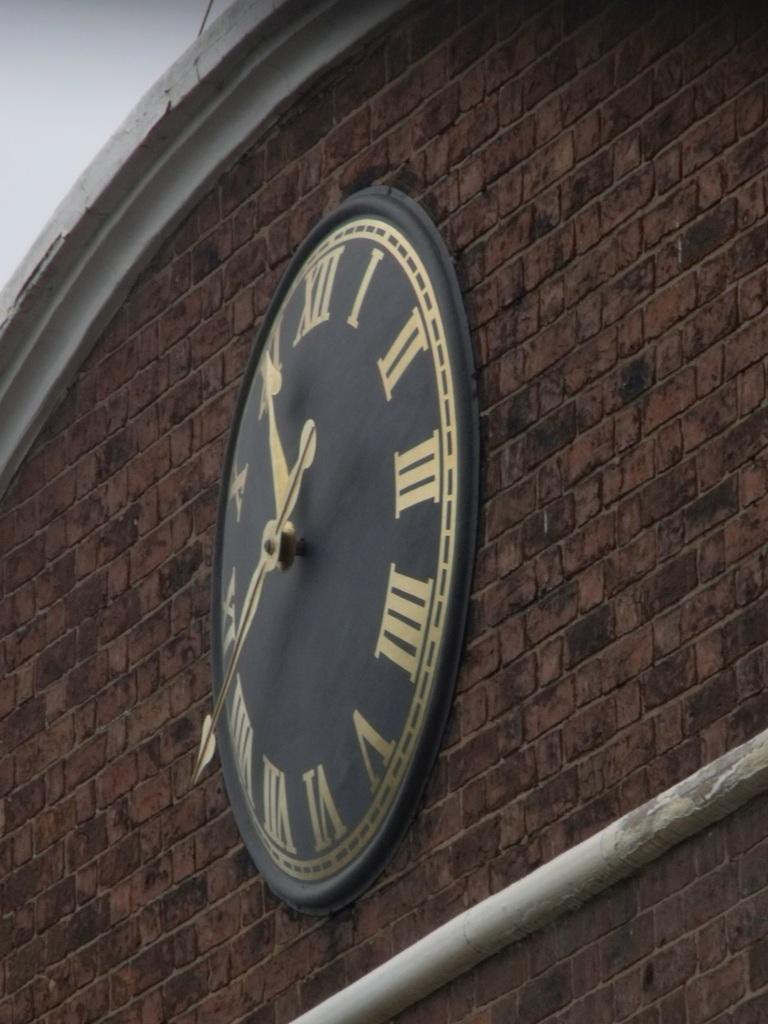What is present on the wall in the image? There is a clock on the wall in the image. Can you describe any other features of the wall? Yes, there is a pipe at the bottom of the wall. Can you see any spots on the wrist of the pig in the image? There is no pig or wrist present in the image. 